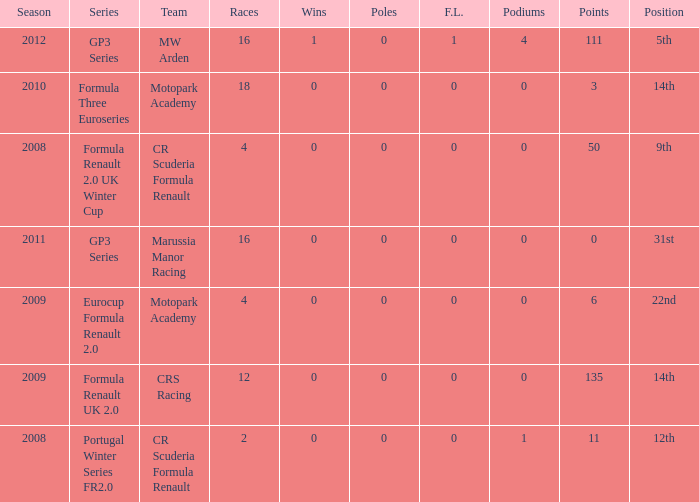What is the least amount of podiums? 0.0. 